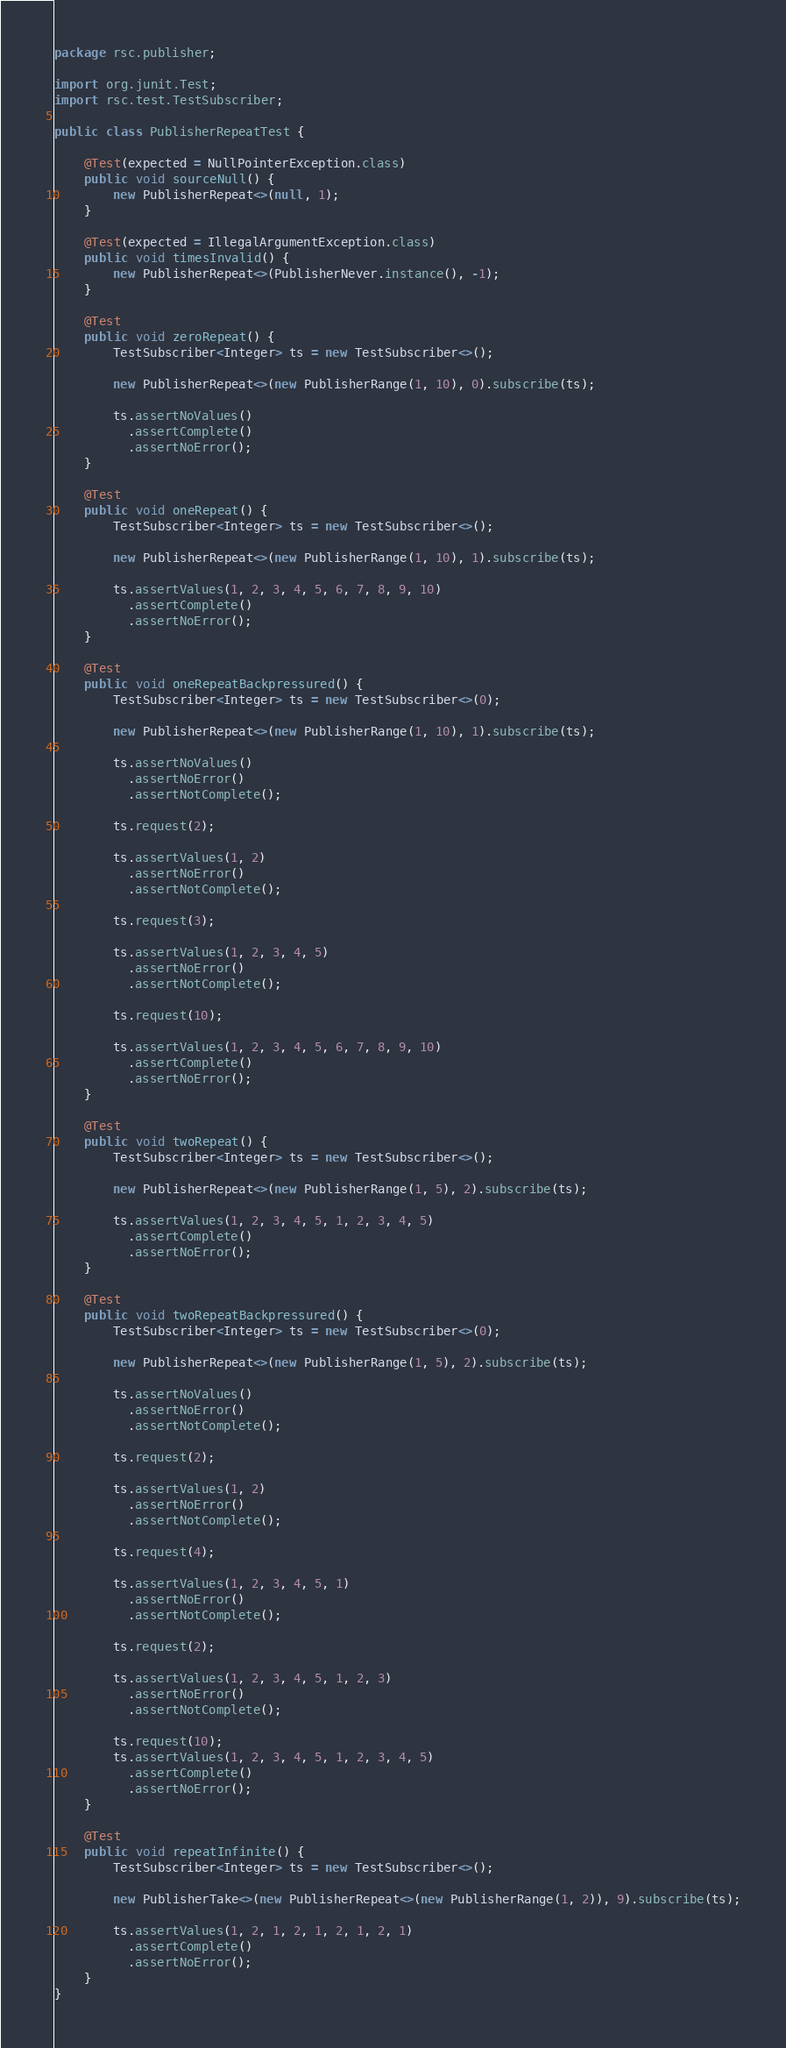<code> <loc_0><loc_0><loc_500><loc_500><_Java_>package rsc.publisher;

import org.junit.Test;
import rsc.test.TestSubscriber;

public class PublisherRepeatTest {

    @Test(expected = NullPointerException.class)
    public void sourceNull() {
        new PublisherRepeat<>(null, 1);
    }

    @Test(expected = IllegalArgumentException.class)
    public void timesInvalid() {
        new PublisherRepeat<>(PublisherNever.instance(), -1);
    }

    @Test
    public void zeroRepeat() {
        TestSubscriber<Integer> ts = new TestSubscriber<>();

        new PublisherRepeat<>(new PublisherRange(1, 10), 0).subscribe(ts);

        ts.assertNoValues()
          .assertComplete()
          .assertNoError();
    }

    @Test
    public void oneRepeat() {
        TestSubscriber<Integer> ts = new TestSubscriber<>();

        new PublisherRepeat<>(new PublisherRange(1, 10), 1).subscribe(ts);

        ts.assertValues(1, 2, 3, 4, 5, 6, 7, 8, 9, 10)
          .assertComplete()
          .assertNoError();
    }

    @Test
    public void oneRepeatBackpressured() {
        TestSubscriber<Integer> ts = new TestSubscriber<>(0);

        new PublisherRepeat<>(new PublisherRange(1, 10), 1).subscribe(ts);

        ts.assertNoValues()
          .assertNoError()
          .assertNotComplete();

        ts.request(2);

        ts.assertValues(1, 2)
          .assertNoError()
          .assertNotComplete();

        ts.request(3);

        ts.assertValues(1, 2, 3, 4, 5)
          .assertNoError()
          .assertNotComplete();

        ts.request(10);

        ts.assertValues(1, 2, 3, 4, 5, 6, 7, 8, 9, 10)
          .assertComplete()
          .assertNoError();
    }

    @Test
    public void twoRepeat() {
        TestSubscriber<Integer> ts = new TestSubscriber<>();

        new PublisherRepeat<>(new PublisherRange(1, 5), 2).subscribe(ts);

        ts.assertValues(1, 2, 3, 4, 5, 1, 2, 3, 4, 5)
          .assertComplete()
          .assertNoError();
    }

    @Test
    public void twoRepeatBackpressured() {
        TestSubscriber<Integer> ts = new TestSubscriber<>(0);

        new PublisherRepeat<>(new PublisherRange(1, 5), 2).subscribe(ts);

        ts.assertNoValues()
          .assertNoError()
          .assertNotComplete();

        ts.request(2);

        ts.assertValues(1, 2)
          .assertNoError()
          .assertNotComplete();

        ts.request(4);

        ts.assertValues(1, 2, 3, 4, 5, 1)
          .assertNoError()
          .assertNotComplete();

        ts.request(2);

        ts.assertValues(1, 2, 3, 4, 5, 1, 2, 3)
          .assertNoError()
          .assertNotComplete();

        ts.request(10);
        ts.assertValues(1, 2, 3, 4, 5, 1, 2, 3, 4, 5)
          .assertComplete()
          .assertNoError();
    }

    @Test
    public void repeatInfinite() {
        TestSubscriber<Integer> ts = new TestSubscriber<>();

        new PublisherTake<>(new PublisherRepeat<>(new PublisherRange(1, 2)), 9).subscribe(ts);

        ts.assertValues(1, 2, 1, 2, 1, 2, 1, 2, 1)
          .assertComplete()
          .assertNoError();
    }
}
</code> 